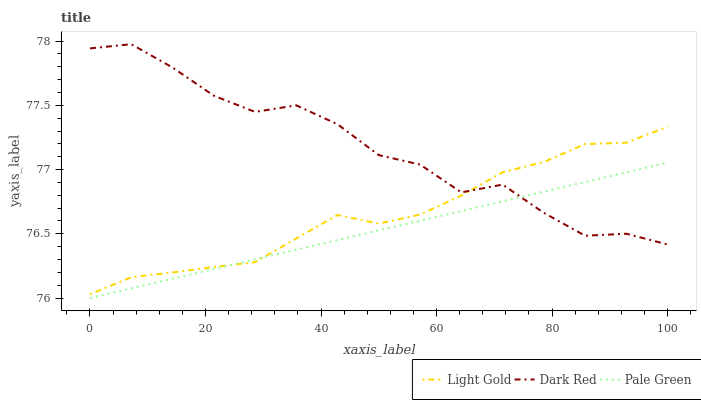Does Pale Green have the minimum area under the curve?
Answer yes or no. Yes. Does Dark Red have the maximum area under the curve?
Answer yes or no. Yes. Does Light Gold have the minimum area under the curve?
Answer yes or no. No. Does Light Gold have the maximum area under the curve?
Answer yes or no. No. Is Pale Green the smoothest?
Answer yes or no. Yes. Is Dark Red the roughest?
Answer yes or no. Yes. Is Light Gold the smoothest?
Answer yes or no. No. Is Light Gold the roughest?
Answer yes or no. No. Does Pale Green have the lowest value?
Answer yes or no. Yes. Does Light Gold have the lowest value?
Answer yes or no. No. Does Dark Red have the highest value?
Answer yes or no. Yes. Does Light Gold have the highest value?
Answer yes or no. No. Does Pale Green intersect Light Gold?
Answer yes or no. Yes. Is Pale Green less than Light Gold?
Answer yes or no. No. Is Pale Green greater than Light Gold?
Answer yes or no. No. 